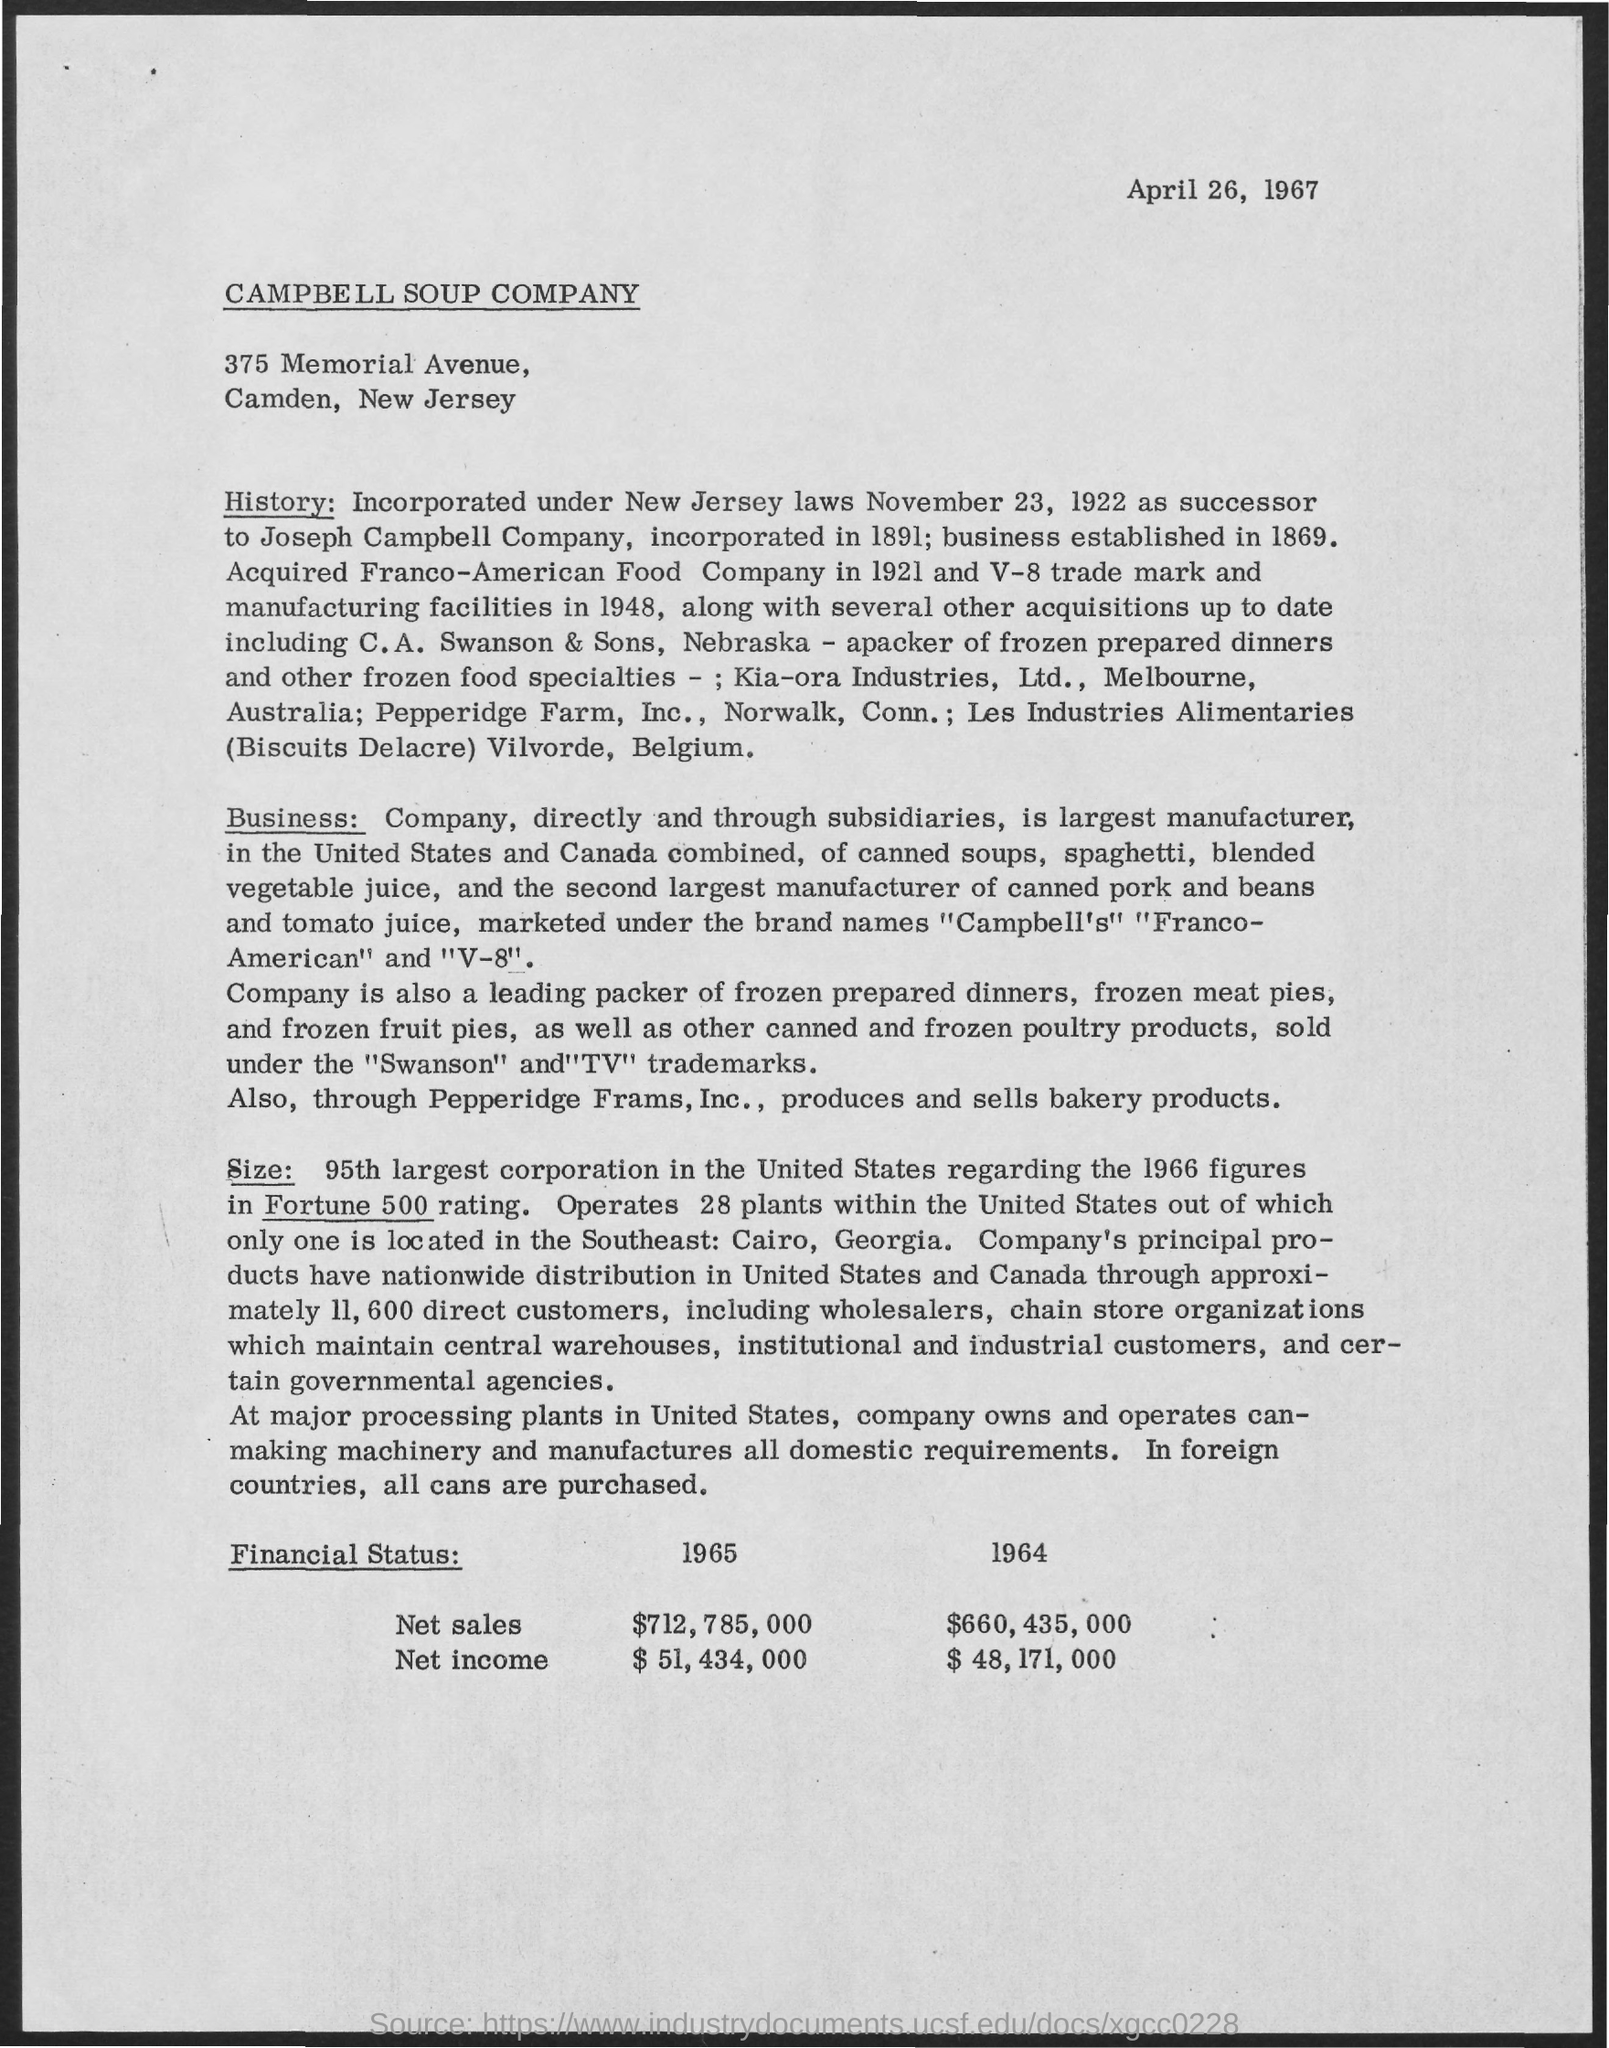What is the date mentioned in the header of the document?
Your response must be concise. APRIL 26, 1967. Which company's details are mentioned in this document?
Give a very brief answer. CAMPBELL SOUP COMPANY. What is the Net sales of Campbell Soup Company for the year 1965?
Ensure brevity in your answer.  $712,785,000. What is the Net Income of Campbell Soup Company for the year 1965?
Offer a very short reply. $51,434,000. What is the Net sales of Campbell Soup Company for the year 1964?
Provide a succinct answer. $660,435,000. What is the Net Income of Campbell Soup Company for the year 1964?
Your response must be concise. $ 48,171,000. 